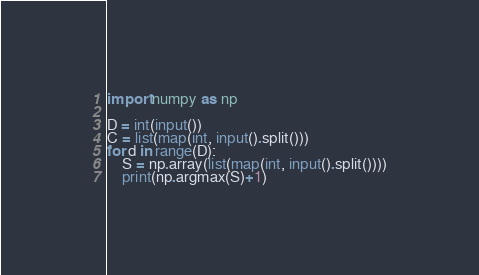<code> <loc_0><loc_0><loc_500><loc_500><_Python_>import numpy as np

D = int(input())
C = list(map(int, input().split()))
for d in range(D):
    S = np.array(list(map(int, input().split())))
    print(np.argmax(S)+1)
</code> 